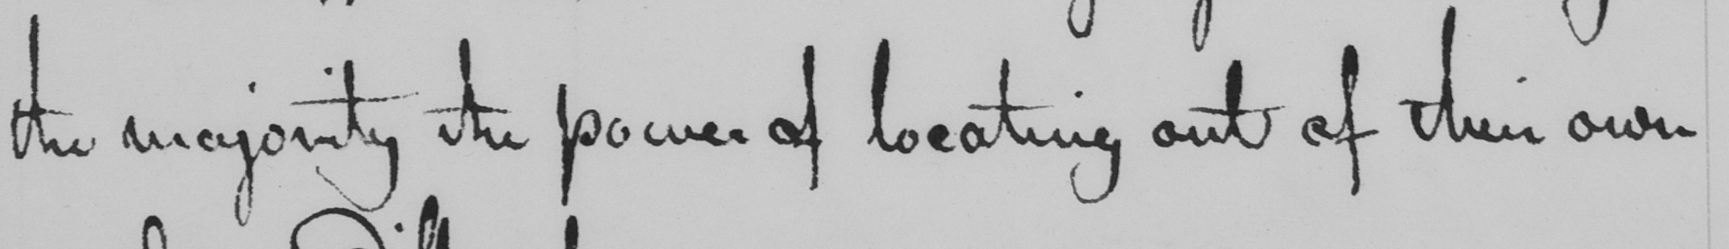Can you tell me what this handwritten text says? the majority the power of locating out of their own 